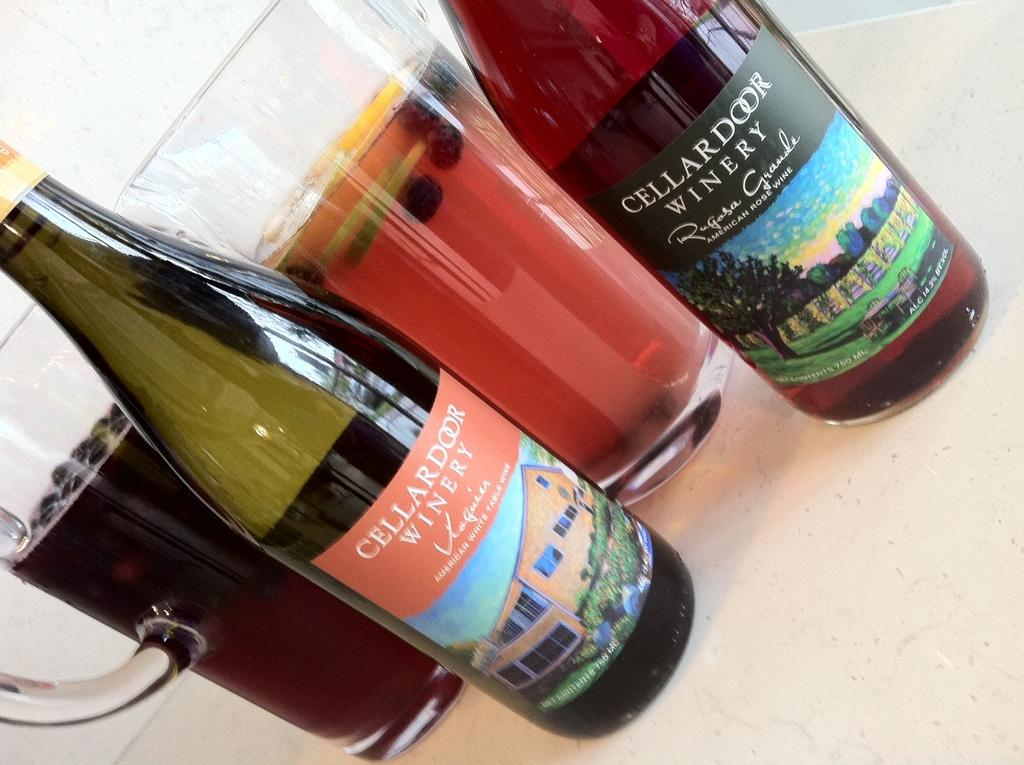<image>
Create a compact narrative representing the image presented. two bottles of Cellar Door Winery wine next to pitchers of cocktails 